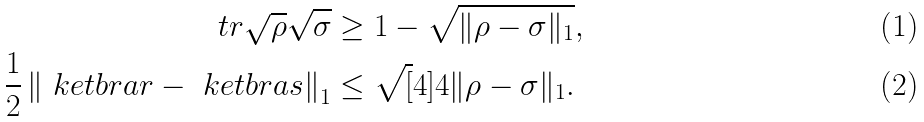Convert formula to latex. <formula><loc_0><loc_0><loc_500><loc_500>\ t r \sqrt { \rho } \sqrt { \sigma } & \geq 1 - \sqrt { \| \rho - \sigma \| _ { 1 } } , \\ \frac { 1 } { 2 } \left \| \ k e t b r a { r } - \ k e t b r a { s } \right \| _ { 1 } & \leq \sqrt { [ } 4 ] { 4 \| \rho - \sigma \| _ { 1 } } .</formula> 